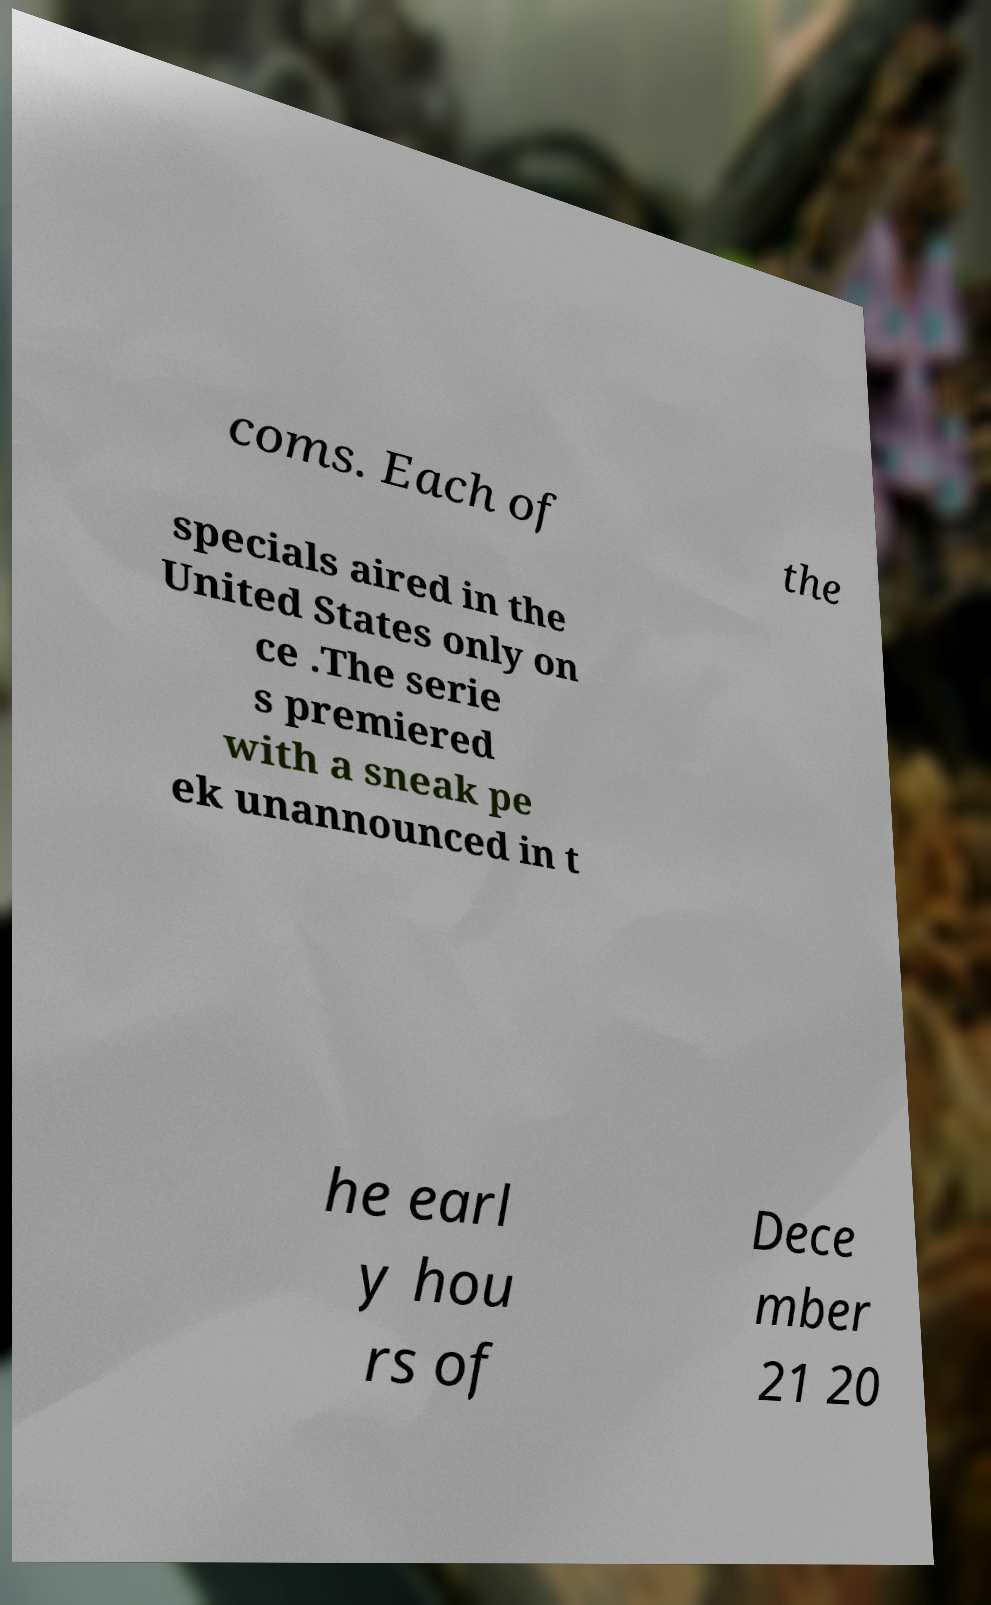What messages or text are displayed in this image? I need them in a readable, typed format. coms. Each of the specials aired in the United States only on ce .The serie s premiered with a sneak pe ek unannounced in t he earl y hou rs of Dece mber 21 20 